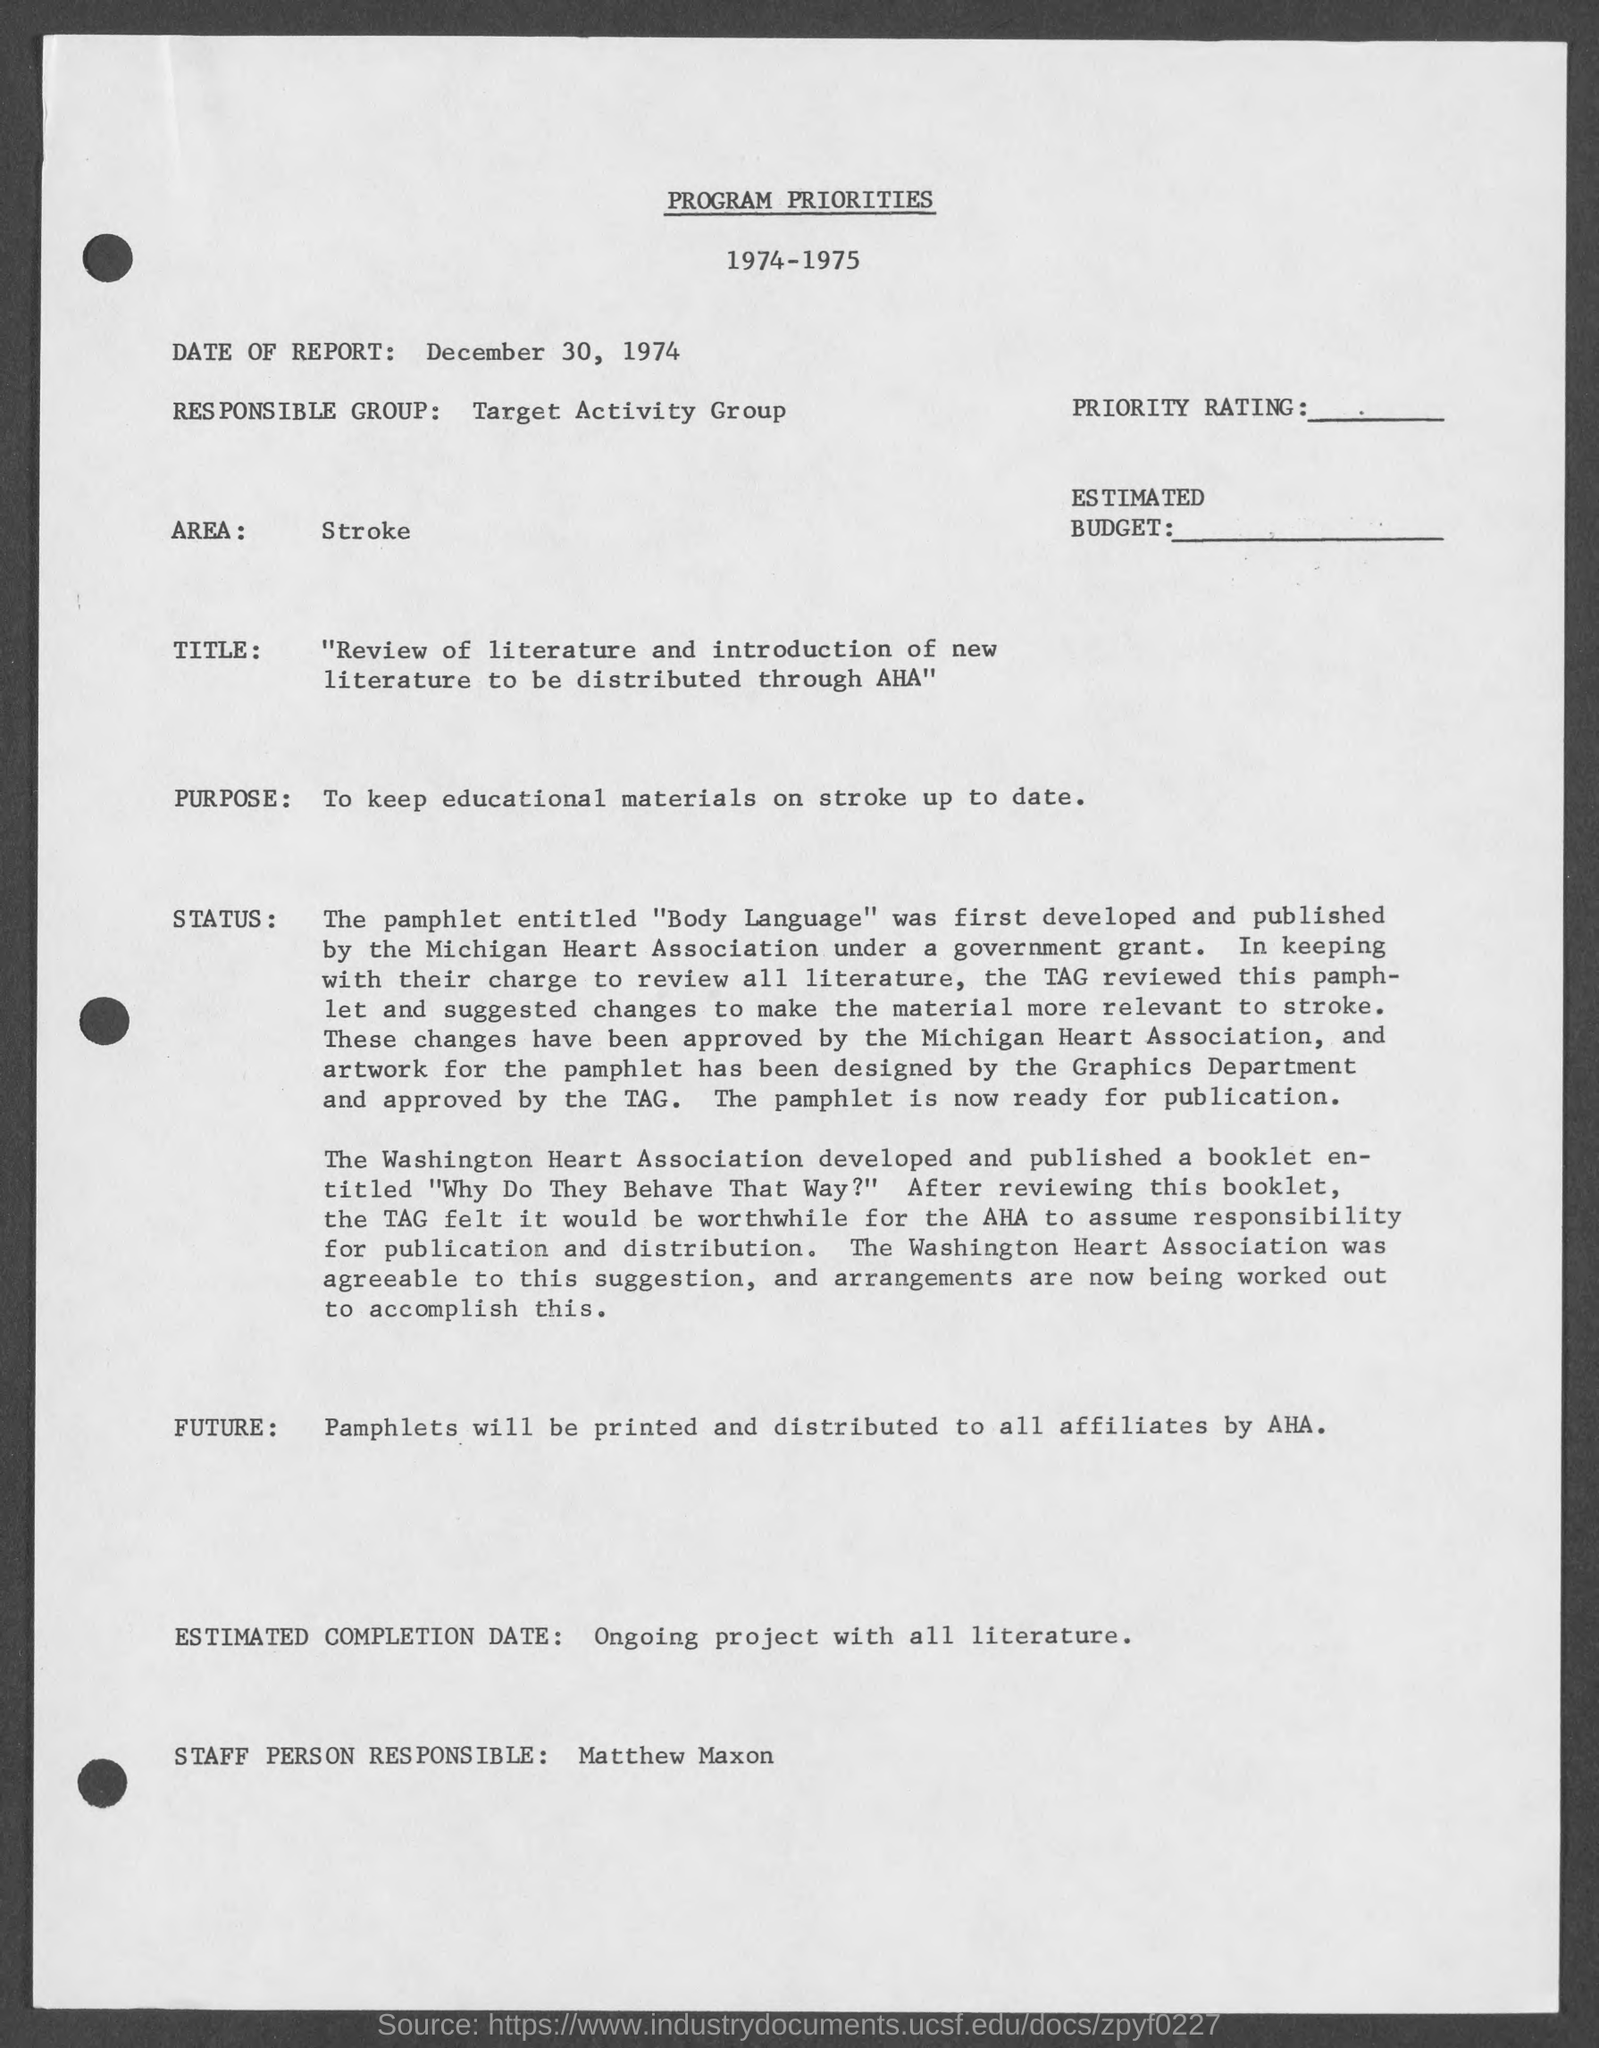Highlight a few significant elements in this photo. The responsible group mentioned in the document is the Target Activity Group. The date on the report as stated in the document is December 30, 1974. The purpose of the program mentioned in the document is to maintain educational materials on stroke current and relevant for medical professionals. The document mentions the area of stroke. 